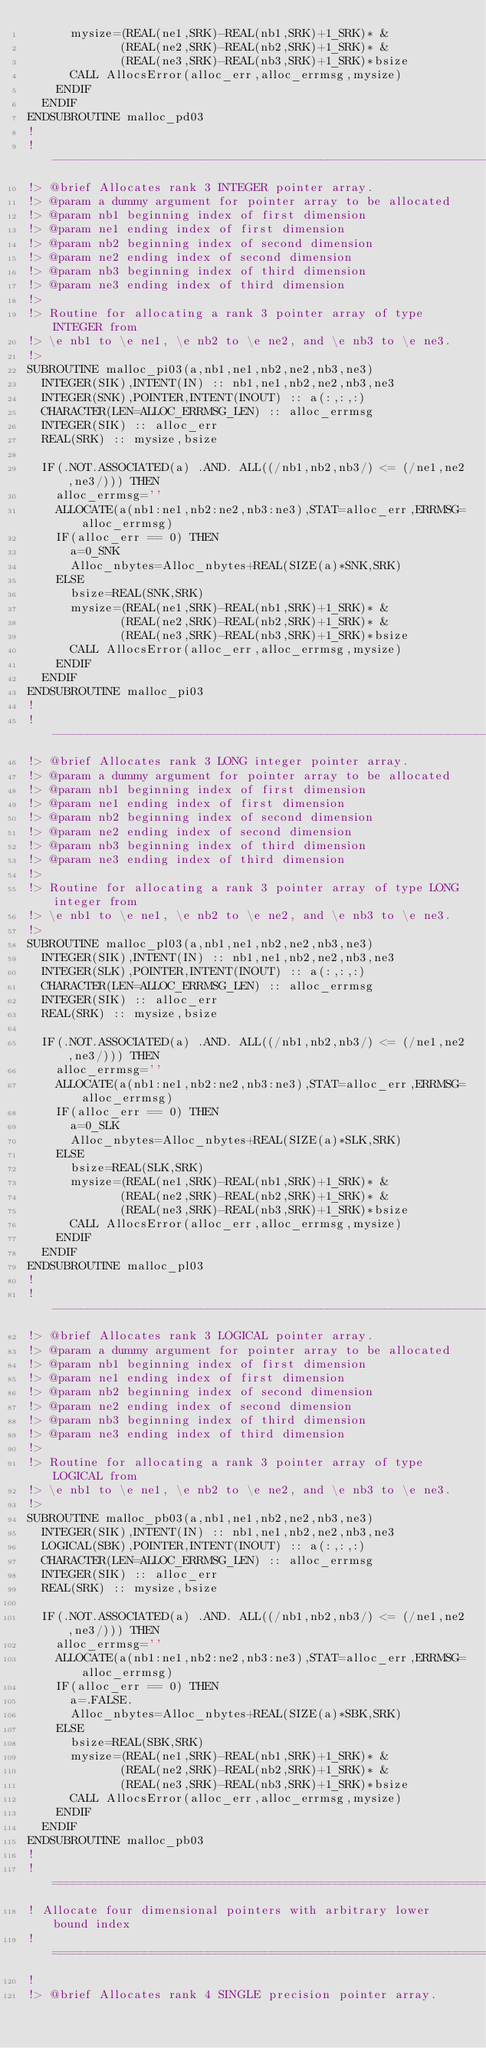<code> <loc_0><loc_0><loc_500><loc_500><_FORTRAN_>      mysize=(REAL(ne1,SRK)-REAL(nb1,SRK)+1_SRK)* &
             (REAL(ne2,SRK)-REAL(nb2,SRK)+1_SRK)* &
             (REAL(ne3,SRK)-REAL(nb3,SRK)+1_SRK)*bsize
      CALL AllocsError(alloc_err,alloc_errmsg,mysize)
    ENDIF
  ENDIF
ENDSUBROUTINE malloc_pd03
!
!-------------------------------------------------------------------------------
!> @brief Allocates rank 3 INTEGER pointer array.
!> @param a dummy argument for pointer array to be allocated
!> @param nb1 beginning index of first dimension
!> @param ne1 ending index of first dimension
!> @param nb2 beginning index of second dimension
!> @param ne2 ending index of second dimension
!> @param nb3 beginning index of third dimension
!> @param ne3 ending index of third dimension
!>
!> Routine for allocating a rank 3 pointer array of type INTEGER from
!> \e nb1 to \e ne1, \e nb2 to \e ne2, and \e nb3 to \e ne3.
!>
SUBROUTINE malloc_pi03(a,nb1,ne1,nb2,ne2,nb3,ne3)
  INTEGER(SIK),INTENT(IN) :: nb1,ne1,nb2,ne2,nb3,ne3
  INTEGER(SNK),POINTER,INTENT(INOUT) :: a(:,:,:)
  CHARACTER(LEN=ALLOC_ERRMSG_LEN) :: alloc_errmsg
  INTEGER(SIK) :: alloc_err
  REAL(SRK) :: mysize,bsize

  IF(.NOT.ASSOCIATED(a) .AND. ALL((/nb1,nb2,nb3/) <= (/ne1,ne2,ne3/))) THEN
    alloc_errmsg=''
    ALLOCATE(a(nb1:ne1,nb2:ne2,nb3:ne3),STAT=alloc_err,ERRMSG=alloc_errmsg)
    IF(alloc_err == 0) THEN
      a=0_SNK
      Alloc_nbytes=Alloc_nbytes+REAL(SIZE(a)*SNK,SRK)
    ELSE
      bsize=REAL(SNK,SRK)
      mysize=(REAL(ne1,SRK)-REAL(nb1,SRK)+1_SRK)* &
             (REAL(ne2,SRK)-REAL(nb2,SRK)+1_SRK)* &
             (REAL(ne3,SRK)-REAL(nb3,SRK)+1_SRK)*bsize
      CALL AllocsError(alloc_err,alloc_errmsg,mysize)
    ENDIF
  ENDIF
ENDSUBROUTINE malloc_pi03
!
!-------------------------------------------------------------------------------
!> @brief Allocates rank 3 LONG integer pointer array.
!> @param a dummy argument for pointer array to be allocated
!> @param nb1 beginning index of first dimension
!> @param ne1 ending index of first dimension
!> @param nb2 beginning index of second dimension
!> @param ne2 ending index of second dimension
!> @param nb3 beginning index of third dimension
!> @param ne3 ending index of third dimension
!>
!> Routine for allocating a rank 3 pointer array of type LONG integer from
!> \e nb1 to \e ne1, \e nb2 to \e ne2, and \e nb3 to \e ne3.
!>
SUBROUTINE malloc_pl03(a,nb1,ne1,nb2,ne2,nb3,ne3)
  INTEGER(SIK),INTENT(IN) :: nb1,ne1,nb2,ne2,nb3,ne3
  INTEGER(SLK),POINTER,INTENT(INOUT) :: a(:,:,:)
  CHARACTER(LEN=ALLOC_ERRMSG_LEN) :: alloc_errmsg
  INTEGER(SIK) :: alloc_err
  REAL(SRK) :: mysize,bsize

  IF(.NOT.ASSOCIATED(a) .AND. ALL((/nb1,nb2,nb3/) <= (/ne1,ne2,ne3/))) THEN
    alloc_errmsg=''
    ALLOCATE(a(nb1:ne1,nb2:ne2,nb3:ne3),STAT=alloc_err,ERRMSG=alloc_errmsg)
    IF(alloc_err == 0) THEN
      a=0_SLK
      Alloc_nbytes=Alloc_nbytes+REAL(SIZE(a)*SLK,SRK)
    ELSE
      bsize=REAL(SLK,SRK)
      mysize=(REAL(ne1,SRK)-REAL(nb1,SRK)+1_SRK)* &
             (REAL(ne2,SRK)-REAL(nb2,SRK)+1_SRK)* &
             (REAL(ne3,SRK)-REAL(nb3,SRK)+1_SRK)*bsize
      CALL AllocsError(alloc_err,alloc_errmsg,mysize)
    ENDIF
  ENDIF
ENDSUBROUTINE malloc_pl03
!
!-------------------------------------------------------------------------------
!> @brief Allocates rank 3 LOGICAL pointer array.
!> @param a dummy argument for pointer array to be allocated
!> @param nb1 beginning index of first dimension
!> @param ne1 ending index of first dimension
!> @param nb2 beginning index of second dimension
!> @param ne2 ending index of second dimension
!> @param nb3 beginning index of third dimension
!> @param ne3 ending index of third dimension
!>
!> Routine for allocating a rank 3 pointer array of type LOGICAL from
!> \e nb1 to \e ne1, \e nb2 to \e ne2, and \e nb3 to \e ne3.
!>
SUBROUTINE malloc_pb03(a,nb1,ne1,nb2,ne2,nb3,ne3)
  INTEGER(SIK),INTENT(IN) :: nb1,ne1,nb2,ne2,nb3,ne3
  LOGICAL(SBK),POINTER,INTENT(INOUT) :: a(:,:,:)
  CHARACTER(LEN=ALLOC_ERRMSG_LEN) :: alloc_errmsg
  INTEGER(SIK) :: alloc_err
  REAL(SRK) :: mysize,bsize

  IF(.NOT.ASSOCIATED(a) .AND. ALL((/nb1,nb2,nb3/) <= (/ne1,ne2,ne3/))) THEN
    alloc_errmsg=''
    ALLOCATE(a(nb1:ne1,nb2:ne2,nb3:ne3),STAT=alloc_err,ERRMSG=alloc_errmsg)
    IF(alloc_err == 0) THEN
      a=.FALSE.
      Alloc_nbytes=Alloc_nbytes+REAL(SIZE(a)*SBK,SRK)
    ELSE
      bsize=REAL(SBK,SRK)
      mysize=(REAL(ne1,SRK)-REAL(nb1,SRK)+1_SRK)* &
             (REAL(ne2,SRK)-REAL(nb2,SRK)+1_SRK)* &
             (REAL(ne3,SRK)-REAL(nb3,SRK)+1_SRK)*bsize
      CALL AllocsError(alloc_err,alloc_errmsg,mysize)
    ENDIF
  ENDIF
ENDSUBROUTINE malloc_pb03
!
!===============================================================================
! Allocate four dimensional pointers with arbitrary lower bound index
!===============================================================================
!
!> @brief Allocates rank 4 SINGLE precision pointer array.</code> 